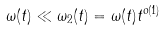<formula> <loc_0><loc_0><loc_500><loc_500>\omega ( t ) \ll \omega _ { 2 } ( t ) = \omega ( t ) t ^ { o ( 1 ) }</formula> 